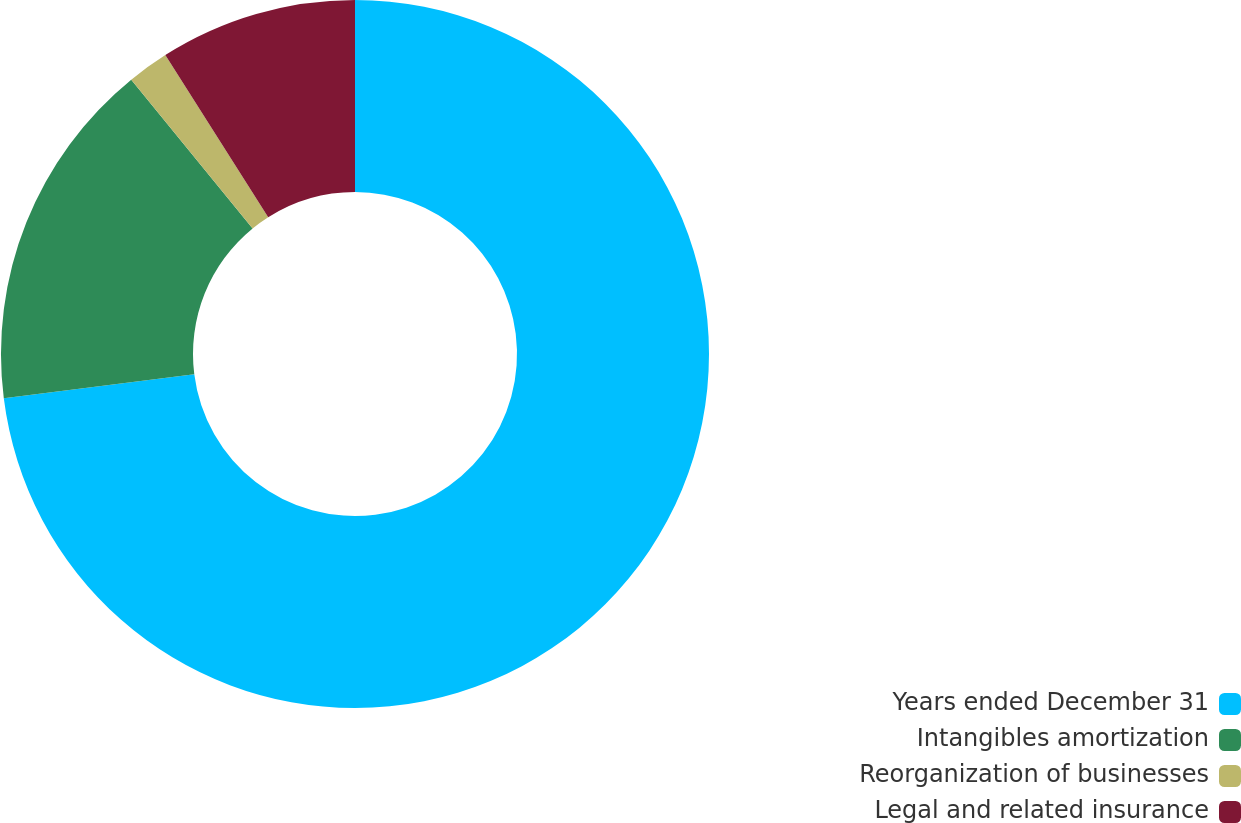<chart> <loc_0><loc_0><loc_500><loc_500><pie_chart><fcel>Years ended December 31<fcel>Intangibles amortization<fcel>Reorganization of businesses<fcel>Legal and related insurance<nl><fcel>73.0%<fcel>16.11%<fcel>1.89%<fcel>9.0%<nl></chart> 